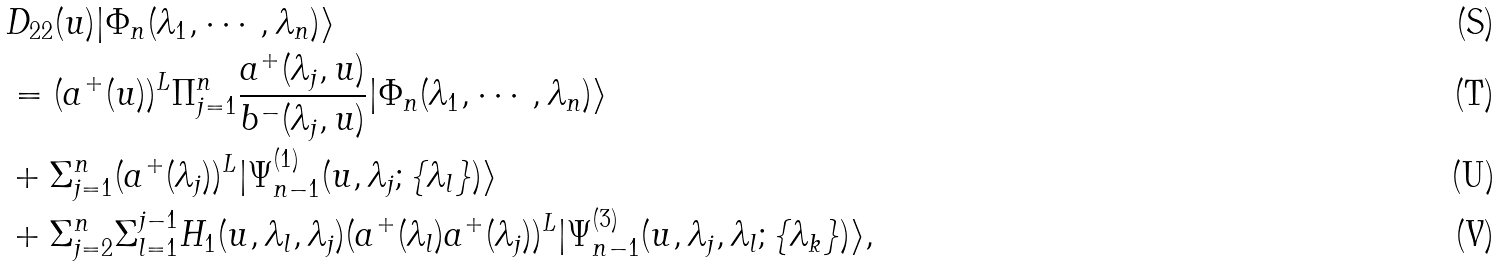Convert formula to latex. <formula><loc_0><loc_0><loc_500><loc_500>& D _ { 2 2 } ( u ) | \Phi _ { n } ( \lambda _ { 1 } , \cdots , \lambda _ { n } ) \rangle \\ & = ( a ^ { + } ( u ) ) ^ { L } \Pi _ { j = 1 } ^ { n } \frac { a ^ { + } ( \lambda _ { j } , u ) } { b ^ { - } ( \lambda _ { j } , u ) } | \Phi _ { n } ( \lambda _ { 1 } , \cdots , \lambda _ { n } ) \rangle \\ & + \Sigma _ { j = 1 } ^ { n } ( a ^ { + } ( \lambda _ { j } ) ) ^ { L } | \Psi _ { n - 1 } ^ { ( 1 ) } ( u , \lambda _ { j } ; \{ \lambda _ { l } \} ) \rangle \\ & + \Sigma _ { j = 2 } ^ { n } \Sigma _ { l = 1 } ^ { j - 1 } H _ { 1 } ( u , \lambda _ { l } , \lambda _ { j } ) ( a ^ { + } ( \lambda _ { l } ) a ^ { + } ( \lambda _ { j } ) ) ^ { L } | \Psi _ { n - 1 } ^ { ( 3 ) } ( u , \lambda _ { j } , \lambda _ { l } ; \{ \lambda _ { k } \} ) \rangle ,</formula> 